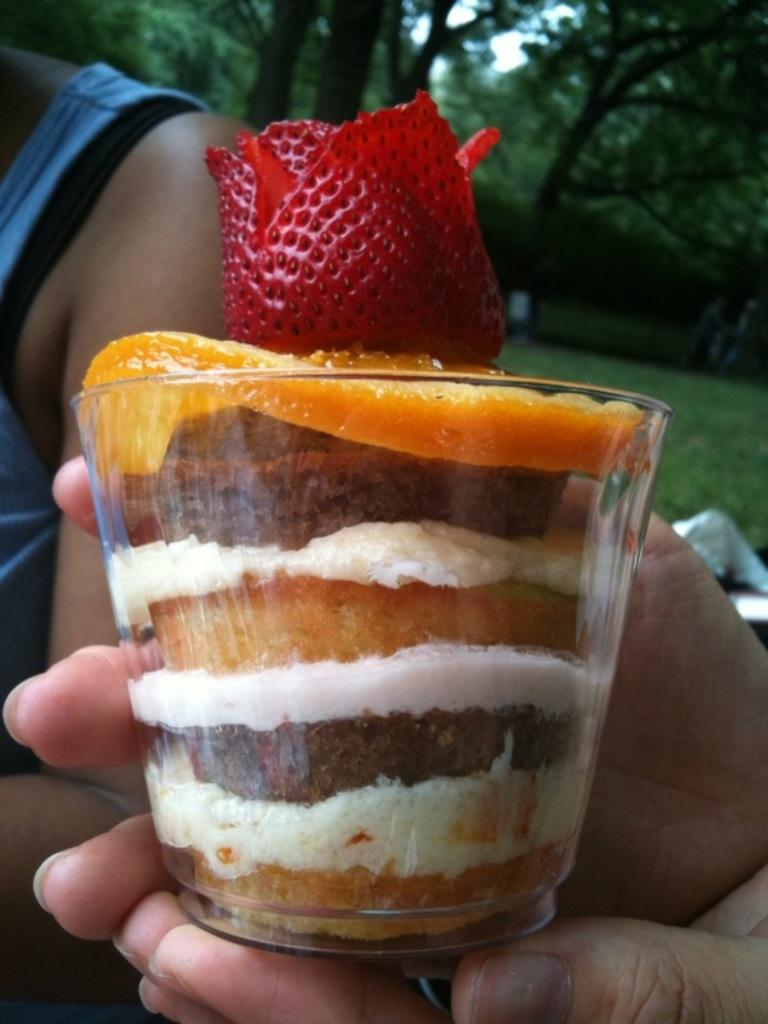What is in the glass that is visible in the image? There is food in the glass in the image. What type of fruit can be seen in the image? There is a strawberry in the image. Who is present in the image? A person is present in the image. What type of vegetation is in the background of the image? There is grass and trees in the background of the image. Can you hear the person in the image coughing? There is no indication of the person coughing in the image, as it only provides visual information. Is there a river visible in the image? There is no river present in the image; it features a glass with food, a strawberry, a person, and a grassy background with trees. 